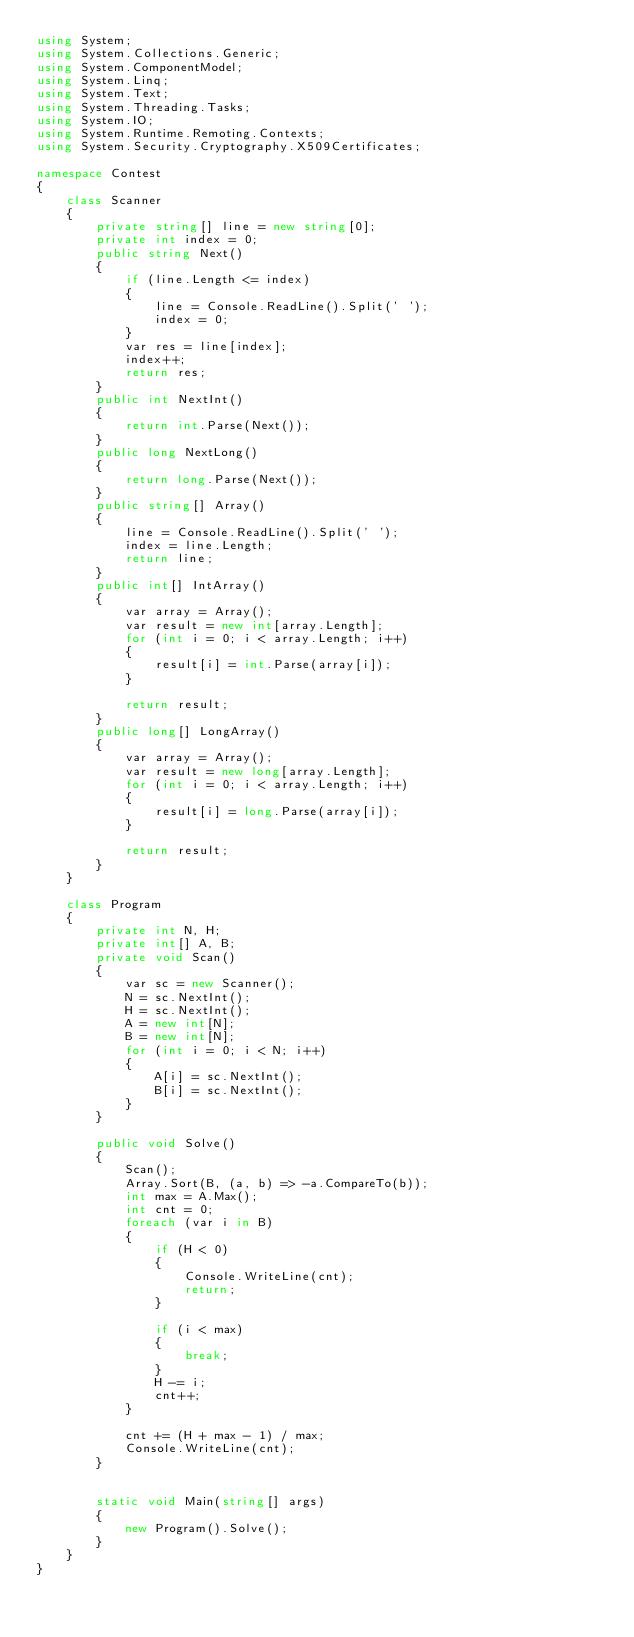Convert code to text. <code><loc_0><loc_0><loc_500><loc_500><_C#_>using System;
using System.Collections.Generic;
using System.ComponentModel;
using System.Linq;
using System.Text;
using System.Threading.Tasks;
using System.IO;
using System.Runtime.Remoting.Contexts;
using System.Security.Cryptography.X509Certificates;

namespace Contest
{
    class Scanner
    {
        private string[] line = new string[0];
        private int index = 0;
        public string Next()
        {
            if (line.Length <= index)
            {
                line = Console.ReadLine().Split(' ');
                index = 0;
            }
            var res = line[index];
            index++;
            return res;
        }
        public int NextInt()
        {
            return int.Parse(Next());
        }
        public long NextLong()
        {
            return long.Parse(Next());
        }
        public string[] Array()
        {
            line = Console.ReadLine().Split(' ');
            index = line.Length;
            return line;
        }
        public int[] IntArray()
        {
            var array = Array();
            var result = new int[array.Length];
            for (int i = 0; i < array.Length; i++)
            {
                result[i] = int.Parse(array[i]);
            }

            return result;
        }
        public long[] LongArray()
        {
            var array = Array();
            var result = new long[array.Length];
            for (int i = 0; i < array.Length; i++)
            {
                result[i] = long.Parse(array[i]);
            }

            return result;
        }
    }

    class Program
    {
        private int N, H;
        private int[] A, B;
        private void Scan()
        {
            var sc = new Scanner();
            N = sc.NextInt();
            H = sc.NextInt();
            A = new int[N];
            B = new int[N];
            for (int i = 0; i < N; i++)
            {
                A[i] = sc.NextInt();
                B[i] = sc.NextInt();
            }
        }

        public void Solve()
        {
            Scan();
            Array.Sort(B, (a, b) => -a.CompareTo(b));
            int max = A.Max();
            int cnt = 0;
            foreach (var i in B)
            {
                if (H < 0)
                {
                    Console.WriteLine(cnt);
                    return;
                }

                if (i < max)
                {
                    break;
                }
                H -= i;
                cnt++;
            }

            cnt += (H + max - 1) / max;
            Console.WriteLine(cnt);
        }


        static void Main(string[] args)
        {
            new Program().Solve();
        }
    }
}</code> 